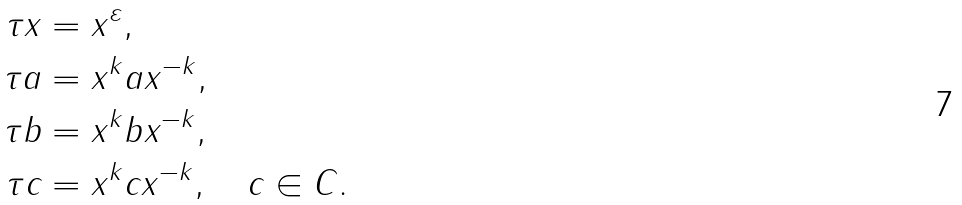Convert formula to latex. <formula><loc_0><loc_0><loc_500><loc_500>\tau x & = x ^ { \varepsilon } , \\ \tau a & = x ^ { k } a x ^ { - k } , \\ \tau b & = x ^ { k } b x ^ { - k } , \\ \tau c & = x ^ { k } c x ^ { - k } , \quad c \in C .</formula> 